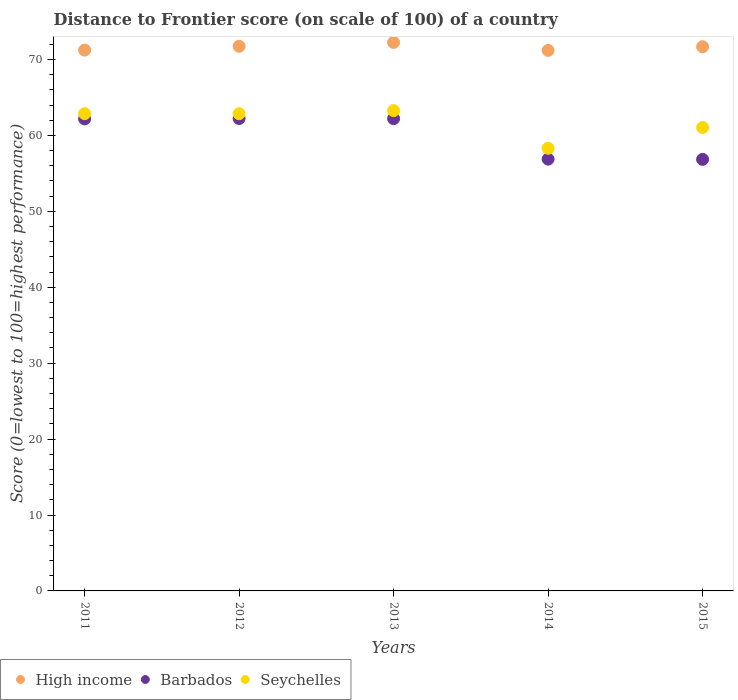How many different coloured dotlines are there?
Offer a terse response. 3. Is the number of dotlines equal to the number of legend labels?
Your answer should be compact. Yes. What is the distance to frontier score of in High income in 2015?
Your response must be concise. 71.69. Across all years, what is the maximum distance to frontier score of in Barbados?
Ensure brevity in your answer.  62.23. Across all years, what is the minimum distance to frontier score of in Barbados?
Give a very brief answer. 56.85. In which year was the distance to frontier score of in Barbados maximum?
Give a very brief answer. 2012. What is the total distance to frontier score of in Seychelles in the graph?
Ensure brevity in your answer.  308.36. What is the difference between the distance to frontier score of in Seychelles in 2011 and that in 2015?
Your response must be concise. 1.82. What is the difference between the distance to frontier score of in High income in 2014 and the distance to frontier score of in Barbados in 2012?
Give a very brief answer. 8.97. What is the average distance to frontier score of in Seychelles per year?
Make the answer very short. 61.67. In the year 2014, what is the difference between the distance to frontier score of in Barbados and distance to frontier score of in High income?
Provide a succinct answer. -14.32. What is the ratio of the distance to frontier score of in High income in 2013 to that in 2014?
Provide a short and direct response. 1.01. Is the difference between the distance to frontier score of in Barbados in 2013 and 2015 greater than the difference between the distance to frontier score of in High income in 2013 and 2015?
Keep it short and to the point. Yes. What is the difference between the highest and the second highest distance to frontier score of in High income?
Offer a very short reply. 0.51. What is the difference between the highest and the lowest distance to frontier score of in Barbados?
Your answer should be very brief. 5.38. Is the sum of the distance to frontier score of in High income in 2011 and 2013 greater than the maximum distance to frontier score of in Seychelles across all years?
Make the answer very short. Yes. Is the distance to frontier score of in High income strictly less than the distance to frontier score of in Barbados over the years?
Your answer should be compact. No. What is the difference between two consecutive major ticks on the Y-axis?
Keep it short and to the point. 10. Does the graph contain grids?
Provide a short and direct response. No. How are the legend labels stacked?
Ensure brevity in your answer.  Horizontal. What is the title of the graph?
Keep it short and to the point. Distance to Frontier score (on scale of 100) of a country. Does "Mauritius" appear as one of the legend labels in the graph?
Make the answer very short. No. What is the label or title of the Y-axis?
Provide a succinct answer. Score (0=lowest to 100=highest performance). What is the Score (0=lowest to 100=highest performance) of High income in 2011?
Make the answer very short. 71.24. What is the Score (0=lowest to 100=highest performance) of Barbados in 2011?
Your answer should be very brief. 62.18. What is the Score (0=lowest to 100=highest performance) of Seychelles in 2011?
Offer a very short reply. 62.87. What is the Score (0=lowest to 100=highest performance) in High income in 2012?
Your answer should be very brief. 71.74. What is the Score (0=lowest to 100=highest performance) in Barbados in 2012?
Keep it short and to the point. 62.23. What is the Score (0=lowest to 100=highest performance) of Seychelles in 2012?
Ensure brevity in your answer.  62.86. What is the Score (0=lowest to 100=highest performance) in High income in 2013?
Ensure brevity in your answer.  72.25. What is the Score (0=lowest to 100=highest performance) of Barbados in 2013?
Offer a very short reply. 62.21. What is the Score (0=lowest to 100=highest performance) of Seychelles in 2013?
Make the answer very short. 63.27. What is the Score (0=lowest to 100=highest performance) of High income in 2014?
Make the answer very short. 71.2. What is the Score (0=lowest to 100=highest performance) of Barbados in 2014?
Make the answer very short. 56.88. What is the Score (0=lowest to 100=highest performance) of Seychelles in 2014?
Make the answer very short. 58.31. What is the Score (0=lowest to 100=highest performance) of High income in 2015?
Offer a very short reply. 71.69. What is the Score (0=lowest to 100=highest performance) of Barbados in 2015?
Your response must be concise. 56.85. What is the Score (0=lowest to 100=highest performance) in Seychelles in 2015?
Provide a succinct answer. 61.05. Across all years, what is the maximum Score (0=lowest to 100=highest performance) of High income?
Your answer should be very brief. 72.25. Across all years, what is the maximum Score (0=lowest to 100=highest performance) of Barbados?
Provide a short and direct response. 62.23. Across all years, what is the maximum Score (0=lowest to 100=highest performance) in Seychelles?
Make the answer very short. 63.27. Across all years, what is the minimum Score (0=lowest to 100=highest performance) in High income?
Offer a terse response. 71.2. Across all years, what is the minimum Score (0=lowest to 100=highest performance) in Barbados?
Ensure brevity in your answer.  56.85. Across all years, what is the minimum Score (0=lowest to 100=highest performance) in Seychelles?
Your answer should be very brief. 58.31. What is the total Score (0=lowest to 100=highest performance) of High income in the graph?
Ensure brevity in your answer.  358.13. What is the total Score (0=lowest to 100=highest performance) of Barbados in the graph?
Your response must be concise. 300.35. What is the total Score (0=lowest to 100=highest performance) of Seychelles in the graph?
Keep it short and to the point. 308.36. What is the difference between the Score (0=lowest to 100=highest performance) in High income in 2011 and that in 2012?
Offer a terse response. -0.5. What is the difference between the Score (0=lowest to 100=highest performance) of Barbados in 2011 and that in 2012?
Provide a short and direct response. -0.05. What is the difference between the Score (0=lowest to 100=highest performance) in High income in 2011 and that in 2013?
Provide a succinct answer. -1.01. What is the difference between the Score (0=lowest to 100=highest performance) of Barbados in 2011 and that in 2013?
Provide a succinct answer. -0.03. What is the difference between the Score (0=lowest to 100=highest performance) of Seychelles in 2011 and that in 2013?
Make the answer very short. -0.4. What is the difference between the Score (0=lowest to 100=highest performance) in High income in 2011 and that in 2014?
Offer a terse response. 0.04. What is the difference between the Score (0=lowest to 100=highest performance) of Barbados in 2011 and that in 2014?
Your answer should be very brief. 5.3. What is the difference between the Score (0=lowest to 100=highest performance) of Seychelles in 2011 and that in 2014?
Make the answer very short. 4.56. What is the difference between the Score (0=lowest to 100=highest performance) of High income in 2011 and that in 2015?
Ensure brevity in your answer.  -0.44. What is the difference between the Score (0=lowest to 100=highest performance) of Barbados in 2011 and that in 2015?
Make the answer very short. 5.33. What is the difference between the Score (0=lowest to 100=highest performance) in Seychelles in 2011 and that in 2015?
Keep it short and to the point. 1.82. What is the difference between the Score (0=lowest to 100=highest performance) of High income in 2012 and that in 2013?
Your response must be concise. -0.51. What is the difference between the Score (0=lowest to 100=highest performance) of Barbados in 2012 and that in 2013?
Your response must be concise. 0.02. What is the difference between the Score (0=lowest to 100=highest performance) of Seychelles in 2012 and that in 2013?
Your answer should be very brief. -0.41. What is the difference between the Score (0=lowest to 100=highest performance) of High income in 2012 and that in 2014?
Keep it short and to the point. 0.54. What is the difference between the Score (0=lowest to 100=highest performance) in Barbados in 2012 and that in 2014?
Ensure brevity in your answer.  5.35. What is the difference between the Score (0=lowest to 100=highest performance) in Seychelles in 2012 and that in 2014?
Your answer should be compact. 4.55. What is the difference between the Score (0=lowest to 100=highest performance) in High income in 2012 and that in 2015?
Give a very brief answer. 0.05. What is the difference between the Score (0=lowest to 100=highest performance) of Barbados in 2012 and that in 2015?
Provide a succinct answer. 5.38. What is the difference between the Score (0=lowest to 100=highest performance) in Seychelles in 2012 and that in 2015?
Provide a short and direct response. 1.81. What is the difference between the Score (0=lowest to 100=highest performance) of High income in 2013 and that in 2014?
Make the answer very short. 1.05. What is the difference between the Score (0=lowest to 100=highest performance) in Barbados in 2013 and that in 2014?
Your response must be concise. 5.33. What is the difference between the Score (0=lowest to 100=highest performance) in Seychelles in 2013 and that in 2014?
Your answer should be compact. 4.96. What is the difference between the Score (0=lowest to 100=highest performance) of High income in 2013 and that in 2015?
Offer a very short reply. 0.56. What is the difference between the Score (0=lowest to 100=highest performance) of Barbados in 2013 and that in 2015?
Keep it short and to the point. 5.36. What is the difference between the Score (0=lowest to 100=highest performance) of Seychelles in 2013 and that in 2015?
Offer a terse response. 2.22. What is the difference between the Score (0=lowest to 100=highest performance) of High income in 2014 and that in 2015?
Give a very brief answer. -0.49. What is the difference between the Score (0=lowest to 100=highest performance) of Seychelles in 2014 and that in 2015?
Offer a very short reply. -2.74. What is the difference between the Score (0=lowest to 100=highest performance) of High income in 2011 and the Score (0=lowest to 100=highest performance) of Barbados in 2012?
Your answer should be compact. 9.01. What is the difference between the Score (0=lowest to 100=highest performance) in High income in 2011 and the Score (0=lowest to 100=highest performance) in Seychelles in 2012?
Your response must be concise. 8.38. What is the difference between the Score (0=lowest to 100=highest performance) of Barbados in 2011 and the Score (0=lowest to 100=highest performance) of Seychelles in 2012?
Make the answer very short. -0.68. What is the difference between the Score (0=lowest to 100=highest performance) in High income in 2011 and the Score (0=lowest to 100=highest performance) in Barbados in 2013?
Offer a very short reply. 9.03. What is the difference between the Score (0=lowest to 100=highest performance) of High income in 2011 and the Score (0=lowest to 100=highest performance) of Seychelles in 2013?
Your answer should be very brief. 7.97. What is the difference between the Score (0=lowest to 100=highest performance) of Barbados in 2011 and the Score (0=lowest to 100=highest performance) of Seychelles in 2013?
Make the answer very short. -1.09. What is the difference between the Score (0=lowest to 100=highest performance) in High income in 2011 and the Score (0=lowest to 100=highest performance) in Barbados in 2014?
Keep it short and to the point. 14.36. What is the difference between the Score (0=lowest to 100=highest performance) in High income in 2011 and the Score (0=lowest to 100=highest performance) in Seychelles in 2014?
Ensure brevity in your answer.  12.93. What is the difference between the Score (0=lowest to 100=highest performance) in Barbados in 2011 and the Score (0=lowest to 100=highest performance) in Seychelles in 2014?
Your answer should be very brief. 3.87. What is the difference between the Score (0=lowest to 100=highest performance) of High income in 2011 and the Score (0=lowest to 100=highest performance) of Barbados in 2015?
Your answer should be very brief. 14.39. What is the difference between the Score (0=lowest to 100=highest performance) of High income in 2011 and the Score (0=lowest to 100=highest performance) of Seychelles in 2015?
Provide a succinct answer. 10.19. What is the difference between the Score (0=lowest to 100=highest performance) of Barbados in 2011 and the Score (0=lowest to 100=highest performance) of Seychelles in 2015?
Keep it short and to the point. 1.13. What is the difference between the Score (0=lowest to 100=highest performance) of High income in 2012 and the Score (0=lowest to 100=highest performance) of Barbados in 2013?
Offer a very short reply. 9.53. What is the difference between the Score (0=lowest to 100=highest performance) of High income in 2012 and the Score (0=lowest to 100=highest performance) of Seychelles in 2013?
Make the answer very short. 8.47. What is the difference between the Score (0=lowest to 100=highest performance) in Barbados in 2012 and the Score (0=lowest to 100=highest performance) in Seychelles in 2013?
Ensure brevity in your answer.  -1.04. What is the difference between the Score (0=lowest to 100=highest performance) of High income in 2012 and the Score (0=lowest to 100=highest performance) of Barbados in 2014?
Make the answer very short. 14.86. What is the difference between the Score (0=lowest to 100=highest performance) of High income in 2012 and the Score (0=lowest to 100=highest performance) of Seychelles in 2014?
Provide a short and direct response. 13.43. What is the difference between the Score (0=lowest to 100=highest performance) in Barbados in 2012 and the Score (0=lowest to 100=highest performance) in Seychelles in 2014?
Ensure brevity in your answer.  3.92. What is the difference between the Score (0=lowest to 100=highest performance) of High income in 2012 and the Score (0=lowest to 100=highest performance) of Barbados in 2015?
Ensure brevity in your answer.  14.89. What is the difference between the Score (0=lowest to 100=highest performance) of High income in 2012 and the Score (0=lowest to 100=highest performance) of Seychelles in 2015?
Make the answer very short. 10.69. What is the difference between the Score (0=lowest to 100=highest performance) of Barbados in 2012 and the Score (0=lowest to 100=highest performance) of Seychelles in 2015?
Provide a succinct answer. 1.18. What is the difference between the Score (0=lowest to 100=highest performance) of High income in 2013 and the Score (0=lowest to 100=highest performance) of Barbados in 2014?
Offer a very short reply. 15.37. What is the difference between the Score (0=lowest to 100=highest performance) of High income in 2013 and the Score (0=lowest to 100=highest performance) of Seychelles in 2014?
Your answer should be very brief. 13.94. What is the difference between the Score (0=lowest to 100=highest performance) in Barbados in 2013 and the Score (0=lowest to 100=highest performance) in Seychelles in 2014?
Your response must be concise. 3.9. What is the difference between the Score (0=lowest to 100=highest performance) in High income in 2013 and the Score (0=lowest to 100=highest performance) in Barbados in 2015?
Offer a terse response. 15.4. What is the difference between the Score (0=lowest to 100=highest performance) of High income in 2013 and the Score (0=lowest to 100=highest performance) of Seychelles in 2015?
Provide a short and direct response. 11.2. What is the difference between the Score (0=lowest to 100=highest performance) in Barbados in 2013 and the Score (0=lowest to 100=highest performance) in Seychelles in 2015?
Your answer should be compact. 1.16. What is the difference between the Score (0=lowest to 100=highest performance) of High income in 2014 and the Score (0=lowest to 100=highest performance) of Barbados in 2015?
Provide a short and direct response. 14.35. What is the difference between the Score (0=lowest to 100=highest performance) in High income in 2014 and the Score (0=lowest to 100=highest performance) in Seychelles in 2015?
Give a very brief answer. 10.15. What is the difference between the Score (0=lowest to 100=highest performance) in Barbados in 2014 and the Score (0=lowest to 100=highest performance) in Seychelles in 2015?
Your response must be concise. -4.17. What is the average Score (0=lowest to 100=highest performance) in High income per year?
Your answer should be compact. 71.63. What is the average Score (0=lowest to 100=highest performance) of Barbados per year?
Provide a succinct answer. 60.07. What is the average Score (0=lowest to 100=highest performance) of Seychelles per year?
Provide a succinct answer. 61.67. In the year 2011, what is the difference between the Score (0=lowest to 100=highest performance) of High income and Score (0=lowest to 100=highest performance) of Barbados?
Keep it short and to the point. 9.06. In the year 2011, what is the difference between the Score (0=lowest to 100=highest performance) in High income and Score (0=lowest to 100=highest performance) in Seychelles?
Give a very brief answer. 8.37. In the year 2011, what is the difference between the Score (0=lowest to 100=highest performance) of Barbados and Score (0=lowest to 100=highest performance) of Seychelles?
Ensure brevity in your answer.  -0.69. In the year 2012, what is the difference between the Score (0=lowest to 100=highest performance) in High income and Score (0=lowest to 100=highest performance) in Barbados?
Ensure brevity in your answer.  9.51. In the year 2012, what is the difference between the Score (0=lowest to 100=highest performance) of High income and Score (0=lowest to 100=highest performance) of Seychelles?
Provide a short and direct response. 8.88. In the year 2012, what is the difference between the Score (0=lowest to 100=highest performance) in Barbados and Score (0=lowest to 100=highest performance) in Seychelles?
Provide a succinct answer. -0.63. In the year 2013, what is the difference between the Score (0=lowest to 100=highest performance) of High income and Score (0=lowest to 100=highest performance) of Barbados?
Offer a very short reply. 10.04. In the year 2013, what is the difference between the Score (0=lowest to 100=highest performance) in High income and Score (0=lowest to 100=highest performance) in Seychelles?
Provide a succinct answer. 8.98. In the year 2013, what is the difference between the Score (0=lowest to 100=highest performance) in Barbados and Score (0=lowest to 100=highest performance) in Seychelles?
Keep it short and to the point. -1.06. In the year 2014, what is the difference between the Score (0=lowest to 100=highest performance) in High income and Score (0=lowest to 100=highest performance) in Barbados?
Provide a short and direct response. 14.32. In the year 2014, what is the difference between the Score (0=lowest to 100=highest performance) in High income and Score (0=lowest to 100=highest performance) in Seychelles?
Offer a very short reply. 12.89. In the year 2014, what is the difference between the Score (0=lowest to 100=highest performance) in Barbados and Score (0=lowest to 100=highest performance) in Seychelles?
Offer a very short reply. -1.43. In the year 2015, what is the difference between the Score (0=lowest to 100=highest performance) in High income and Score (0=lowest to 100=highest performance) in Barbados?
Your response must be concise. 14.84. In the year 2015, what is the difference between the Score (0=lowest to 100=highest performance) of High income and Score (0=lowest to 100=highest performance) of Seychelles?
Provide a short and direct response. 10.64. What is the ratio of the Score (0=lowest to 100=highest performance) of Barbados in 2011 to that in 2012?
Make the answer very short. 1. What is the ratio of the Score (0=lowest to 100=highest performance) of Seychelles in 2011 to that in 2013?
Provide a short and direct response. 0.99. What is the ratio of the Score (0=lowest to 100=highest performance) of Barbados in 2011 to that in 2014?
Offer a very short reply. 1.09. What is the ratio of the Score (0=lowest to 100=highest performance) in Seychelles in 2011 to that in 2014?
Make the answer very short. 1.08. What is the ratio of the Score (0=lowest to 100=highest performance) in High income in 2011 to that in 2015?
Make the answer very short. 0.99. What is the ratio of the Score (0=lowest to 100=highest performance) of Barbados in 2011 to that in 2015?
Your answer should be very brief. 1.09. What is the ratio of the Score (0=lowest to 100=highest performance) in Seychelles in 2011 to that in 2015?
Provide a succinct answer. 1.03. What is the ratio of the Score (0=lowest to 100=highest performance) in Seychelles in 2012 to that in 2013?
Give a very brief answer. 0.99. What is the ratio of the Score (0=lowest to 100=highest performance) in High income in 2012 to that in 2014?
Your answer should be compact. 1.01. What is the ratio of the Score (0=lowest to 100=highest performance) of Barbados in 2012 to that in 2014?
Ensure brevity in your answer.  1.09. What is the ratio of the Score (0=lowest to 100=highest performance) in Seychelles in 2012 to that in 2014?
Your answer should be compact. 1.08. What is the ratio of the Score (0=lowest to 100=highest performance) of High income in 2012 to that in 2015?
Provide a short and direct response. 1. What is the ratio of the Score (0=lowest to 100=highest performance) of Barbados in 2012 to that in 2015?
Ensure brevity in your answer.  1.09. What is the ratio of the Score (0=lowest to 100=highest performance) of Seychelles in 2012 to that in 2015?
Offer a terse response. 1.03. What is the ratio of the Score (0=lowest to 100=highest performance) in High income in 2013 to that in 2014?
Offer a terse response. 1.01. What is the ratio of the Score (0=lowest to 100=highest performance) of Barbados in 2013 to that in 2014?
Offer a terse response. 1.09. What is the ratio of the Score (0=lowest to 100=highest performance) in Seychelles in 2013 to that in 2014?
Your answer should be compact. 1.09. What is the ratio of the Score (0=lowest to 100=highest performance) of High income in 2013 to that in 2015?
Your answer should be very brief. 1.01. What is the ratio of the Score (0=lowest to 100=highest performance) in Barbados in 2013 to that in 2015?
Provide a short and direct response. 1.09. What is the ratio of the Score (0=lowest to 100=highest performance) of Seychelles in 2013 to that in 2015?
Provide a short and direct response. 1.04. What is the ratio of the Score (0=lowest to 100=highest performance) in High income in 2014 to that in 2015?
Give a very brief answer. 0.99. What is the ratio of the Score (0=lowest to 100=highest performance) in Barbados in 2014 to that in 2015?
Keep it short and to the point. 1. What is the ratio of the Score (0=lowest to 100=highest performance) of Seychelles in 2014 to that in 2015?
Keep it short and to the point. 0.96. What is the difference between the highest and the second highest Score (0=lowest to 100=highest performance) of High income?
Keep it short and to the point. 0.51. What is the difference between the highest and the second highest Score (0=lowest to 100=highest performance) of Seychelles?
Ensure brevity in your answer.  0.4. What is the difference between the highest and the lowest Score (0=lowest to 100=highest performance) of High income?
Your answer should be compact. 1.05. What is the difference between the highest and the lowest Score (0=lowest to 100=highest performance) in Barbados?
Your answer should be compact. 5.38. What is the difference between the highest and the lowest Score (0=lowest to 100=highest performance) in Seychelles?
Your answer should be very brief. 4.96. 